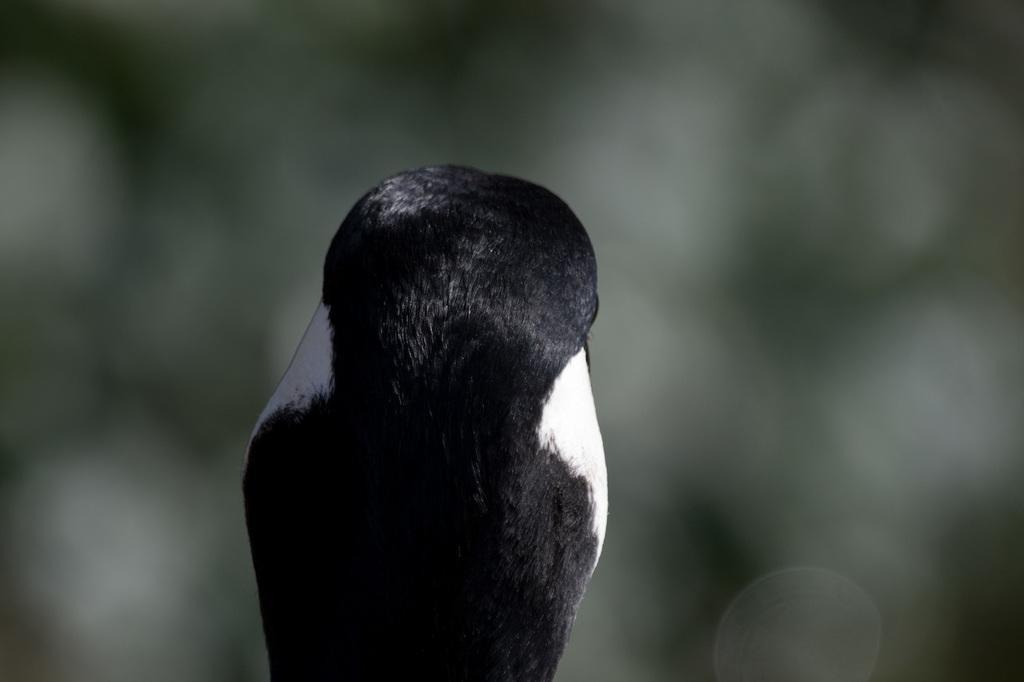Could you give a brief overview of what you see in this image? In the image we can see there is a back pose of an animal. Background of the image is blurred. 